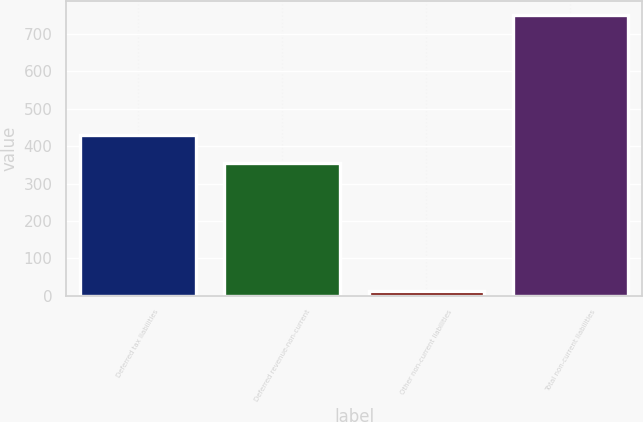Convert chart to OTSL. <chart><loc_0><loc_0><loc_500><loc_500><bar_chart><fcel>Deferred tax liabilities<fcel>Deferred revenue-non-current<fcel>Other non-current liabilities<fcel>Total non-current liabilities<nl><fcel>428.6<fcel>355<fcel>14<fcel>750<nl></chart> 